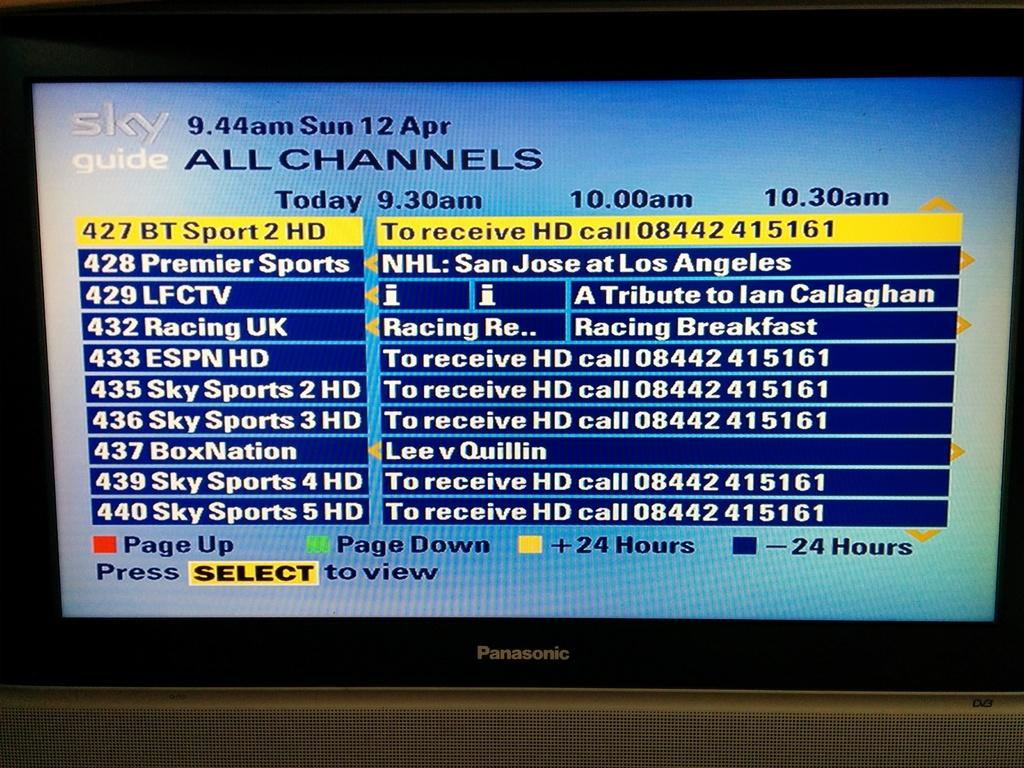What electronic device is present in the image? There is a monitor in the image. What is displayed on the monitor? The monitor is displaying tables with text. Can you see any honey dripping from the tree in the image? There is no tree or honey present in the image; it only features a monitor displaying tables with text. 